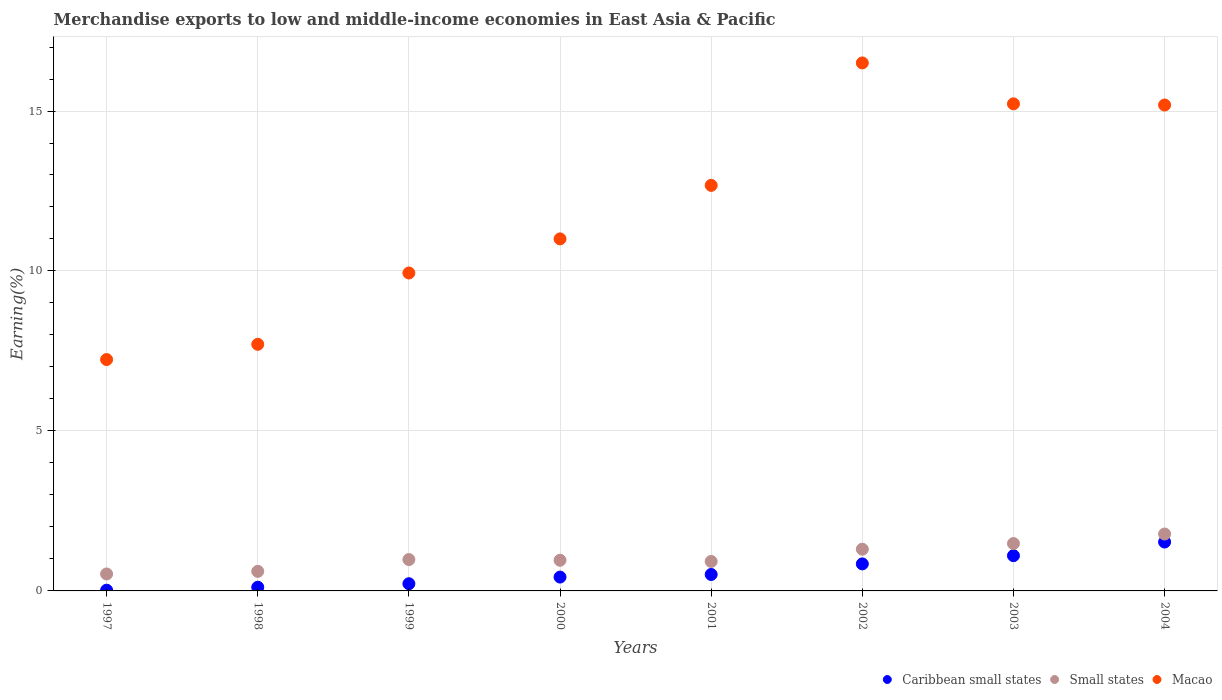How many different coloured dotlines are there?
Your response must be concise. 3. What is the percentage of amount earned from merchandise exports in Small states in 1997?
Your answer should be very brief. 0.53. Across all years, what is the maximum percentage of amount earned from merchandise exports in Macao?
Keep it short and to the point. 16.5. Across all years, what is the minimum percentage of amount earned from merchandise exports in Caribbean small states?
Your answer should be compact. 0.02. In which year was the percentage of amount earned from merchandise exports in Small states maximum?
Provide a succinct answer. 2004. In which year was the percentage of amount earned from merchandise exports in Caribbean small states minimum?
Offer a terse response. 1997. What is the total percentage of amount earned from merchandise exports in Macao in the graph?
Ensure brevity in your answer.  95.47. What is the difference between the percentage of amount earned from merchandise exports in Macao in 1997 and that in 2003?
Offer a very short reply. -7.99. What is the difference between the percentage of amount earned from merchandise exports in Small states in 2004 and the percentage of amount earned from merchandise exports in Caribbean small states in 2000?
Keep it short and to the point. 1.35. What is the average percentage of amount earned from merchandise exports in Caribbean small states per year?
Your answer should be compact. 0.6. In the year 1998, what is the difference between the percentage of amount earned from merchandise exports in Macao and percentage of amount earned from merchandise exports in Small states?
Give a very brief answer. 7.1. In how many years, is the percentage of amount earned from merchandise exports in Macao greater than 3 %?
Your answer should be very brief. 8. What is the ratio of the percentage of amount earned from merchandise exports in Small states in 1999 to that in 2000?
Offer a terse response. 1.02. What is the difference between the highest and the second highest percentage of amount earned from merchandise exports in Small states?
Your answer should be compact. 0.3. What is the difference between the highest and the lowest percentage of amount earned from merchandise exports in Macao?
Your response must be concise. 9.27. In how many years, is the percentage of amount earned from merchandise exports in Macao greater than the average percentage of amount earned from merchandise exports in Macao taken over all years?
Your answer should be very brief. 4. Is the sum of the percentage of amount earned from merchandise exports in Small states in 1998 and 2003 greater than the maximum percentage of amount earned from merchandise exports in Caribbean small states across all years?
Offer a terse response. Yes. Is it the case that in every year, the sum of the percentage of amount earned from merchandise exports in Macao and percentage of amount earned from merchandise exports in Caribbean small states  is greater than the percentage of amount earned from merchandise exports in Small states?
Your response must be concise. Yes. Does the percentage of amount earned from merchandise exports in Small states monotonically increase over the years?
Ensure brevity in your answer.  No. Is the percentage of amount earned from merchandise exports in Macao strictly less than the percentage of amount earned from merchandise exports in Caribbean small states over the years?
Your answer should be very brief. No. Are the values on the major ticks of Y-axis written in scientific E-notation?
Your answer should be very brief. No. Does the graph contain any zero values?
Provide a succinct answer. No. Where does the legend appear in the graph?
Ensure brevity in your answer.  Bottom right. How many legend labels are there?
Your answer should be very brief. 3. What is the title of the graph?
Provide a succinct answer. Merchandise exports to low and middle-income economies in East Asia & Pacific. What is the label or title of the Y-axis?
Make the answer very short. Earning(%). What is the Earning(%) of Caribbean small states in 1997?
Provide a short and direct response. 0.02. What is the Earning(%) of Small states in 1997?
Offer a terse response. 0.53. What is the Earning(%) in Macao in 1997?
Your answer should be very brief. 7.23. What is the Earning(%) of Caribbean small states in 1998?
Your answer should be compact. 0.12. What is the Earning(%) of Small states in 1998?
Your answer should be very brief. 0.61. What is the Earning(%) of Macao in 1998?
Offer a very short reply. 7.71. What is the Earning(%) in Caribbean small states in 1999?
Your answer should be compact. 0.22. What is the Earning(%) in Small states in 1999?
Give a very brief answer. 0.98. What is the Earning(%) in Macao in 1999?
Ensure brevity in your answer.  9.94. What is the Earning(%) of Caribbean small states in 2000?
Your answer should be very brief. 0.43. What is the Earning(%) in Small states in 2000?
Provide a succinct answer. 0.96. What is the Earning(%) of Macao in 2000?
Your response must be concise. 11. What is the Earning(%) of Caribbean small states in 2001?
Provide a succinct answer. 0.51. What is the Earning(%) of Small states in 2001?
Your answer should be very brief. 0.92. What is the Earning(%) in Macao in 2001?
Provide a succinct answer. 12.68. What is the Earning(%) in Caribbean small states in 2002?
Your response must be concise. 0.84. What is the Earning(%) in Small states in 2002?
Offer a terse response. 1.3. What is the Earning(%) of Macao in 2002?
Provide a succinct answer. 16.5. What is the Earning(%) in Caribbean small states in 2003?
Provide a short and direct response. 1.1. What is the Earning(%) in Small states in 2003?
Offer a very short reply. 1.48. What is the Earning(%) in Macao in 2003?
Your answer should be compact. 15.22. What is the Earning(%) in Caribbean small states in 2004?
Provide a short and direct response. 1.53. What is the Earning(%) of Small states in 2004?
Your answer should be very brief. 1.78. What is the Earning(%) in Macao in 2004?
Keep it short and to the point. 15.19. Across all years, what is the maximum Earning(%) in Caribbean small states?
Your response must be concise. 1.53. Across all years, what is the maximum Earning(%) in Small states?
Offer a terse response. 1.78. Across all years, what is the maximum Earning(%) of Macao?
Your answer should be compact. 16.5. Across all years, what is the minimum Earning(%) of Caribbean small states?
Your response must be concise. 0.02. Across all years, what is the minimum Earning(%) of Small states?
Your answer should be very brief. 0.53. Across all years, what is the minimum Earning(%) in Macao?
Make the answer very short. 7.23. What is the total Earning(%) in Caribbean small states in the graph?
Give a very brief answer. 4.79. What is the total Earning(%) of Small states in the graph?
Ensure brevity in your answer.  8.56. What is the total Earning(%) in Macao in the graph?
Offer a terse response. 95.47. What is the difference between the Earning(%) in Caribbean small states in 1997 and that in 1998?
Provide a short and direct response. -0.09. What is the difference between the Earning(%) of Small states in 1997 and that in 1998?
Offer a terse response. -0.08. What is the difference between the Earning(%) of Macao in 1997 and that in 1998?
Provide a short and direct response. -0.48. What is the difference between the Earning(%) in Caribbean small states in 1997 and that in 1999?
Provide a short and direct response. -0.2. What is the difference between the Earning(%) in Small states in 1997 and that in 1999?
Keep it short and to the point. -0.45. What is the difference between the Earning(%) of Macao in 1997 and that in 1999?
Provide a short and direct response. -2.71. What is the difference between the Earning(%) of Caribbean small states in 1997 and that in 2000?
Provide a short and direct response. -0.41. What is the difference between the Earning(%) of Small states in 1997 and that in 2000?
Make the answer very short. -0.43. What is the difference between the Earning(%) of Macao in 1997 and that in 2000?
Ensure brevity in your answer.  -3.77. What is the difference between the Earning(%) of Caribbean small states in 1997 and that in 2001?
Ensure brevity in your answer.  -0.49. What is the difference between the Earning(%) in Small states in 1997 and that in 2001?
Offer a terse response. -0.39. What is the difference between the Earning(%) of Macao in 1997 and that in 2001?
Give a very brief answer. -5.44. What is the difference between the Earning(%) of Caribbean small states in 1997 and that in 2002?
Your answer should be compact. -0.82. What is the difference between the Earning(%) in Small states in 1997 and that in 2002?
Make the answer very short. -0.77. What is the difference between the Earning(%) in Macao in 1997 and that in 2002?
Provide a short and direct response. -9.27. What is the difference between the Earning(%) in Caribbean small states in 1997 and that in 2003?
Your answer should be compact. -1.08. What is the difference between the Earning(%) in Small states in 1997 and that in 2003?
Ensure brevity in your answer.  -0.95. What is the difference between the Earning(%) in Macao in 1997 and that in 2003?
Your response must be concise. -7.99. What is the difference between the Earning(%) of Caribbean small states in 1997 and that in 2004?
Ensure brevity in your answer.  -1.5. What is the difference between the Earning(%) of Small states in 1997 and that in 2004?
Make the answer very short. -1.25. What is the difference between the Earning(%) in Macao in 1997 and that in 2004?
Provide a short and direct response. -7.96. What is the difference between the Earning(%) of Caribbean small states in 1998 and that in 1999?
Make the answer very short. -0.11. What is the difference between the Earning(%) in Small states in 1998 and that in 1999?
Offer a terse response. -0.37. What is the difference between the Earning(%) in Macao in 1998 and that in 1999?
Provide a succinct answer. -2.23. What is the difference between the Earning(%) of Caribbean small states in 1998 and that in 2000?
Offer a very short reply. -0.32. What is the difference between the Earning(%) in Small states in 1998 and that in 2000?
Provide a short and direct response. -0.35. What is the difference between the Earning(%) in Macao in 1998 and that in 2000?
Provide a succinct answer. -3.3. What is the difference between the Earning(%) of Caribbean small states in 1998 and that in 2001?
Your response must be concise. -0.4. What is the difference between the Earning(%) of Small states in 1998 and that in 2001?
Give a very brief answer. -0.31. What is the difference between the Earning(%) in Macao in 1998 and that in 2001?
Offer a terse response. -4.97. What is the difference between the Earning(%) in Caribbean small states in 1998 and that in 2002?
Provide a short and direct response. -0.73. What is the difference between the Earning(%) in Small states in 1998 and that in 2002?
Your answer should be compact. -0.69. What is the difference between the Earning(%) of Macao in 1998 and that in 2002?
Provide a short and direct response. -8.79. What is the difference between the Earning(%) of Caribbean small states in 1998 and that in 2003?
Your answer should be compact. -0.99. What is the difference between the Earning(%) of Small states in 1998 and that in 2003?
Make the answer very short. -0.87. What is the difference between the Earning(%) of Macao in 1998 and that in 2003?
Make the answer very short. -7.52. What is the difference between the Earning(%) of Caribbean small states in 1998 and that in 2004?
Provide a short and direct response. -1.41. What is the difference between the Earning(%) of Small states in 1998 and that in 2004?
Make the answer very short. -1.17. What is the difference between the Earning(%) in Macao in 1998 and that in 2004?
Offer a very short reply. -7.48. What is the difference between the Earning(%) in Caribbean small states in 1999 and that in 2000?
Your response must be concise. -0.21. What is the difference between the Earning(%) in Small states in 1999 and that in 2000?
Give a very brief answer. 0.02. What is the difference between the Earning(%) of Macao in 1999 and that in 2000?
Ensure brevity in your answer.  -1.07. What is the difference between the Earning(%) in Caribbean small states in 1999 and that in 2001?
Make the answer very short. -0.29. What is the difference between the Earning(%) of Small states in 1999 and that in 2001?
Keep it short and to the point. 0.06. What is the difference between the Earning(%) in Macao in 1999 and that in 2001?
Keep it short and to the point. -2.74. What is the difference between the Earning(%) of Caribbean small states in 1999 and that in 2002?
Provide a short and direct response. -0.62. What is the difference between the Earning(%) of Small states in 1999 and that in 2002?
Make the answer very short. -0.32. What is the difference between the Earning(%) of Macao in 1999 and that in 2002?
Provide a short and direct response. -6.57. What is the difference between the Earning(%) of Caribbean small states in 1999 and that in 2003?
Make the answer very short. -0.88. What is the difference between the Earning(%) in Small states in 1999 and that in 2003?
Your answer should be very brief. -0.5. What is the difference between the Earning(%) in Macao in 1999 and that in 2003?
Offer a very short reply. -5.29. What is the difference between the Earning(%) of Caribbean small states in 1999 and that in 2004?
Give a very brief answer. -1.3. What is the difference between the Earning(%) of Small states in 1999 and that in 2004?
Offer a very short reply. -0.8. What is the difference between the Earning(%) in Macao in 1999 and that in 2004?
Offer a terse response. -5.25. What is the difference between the Earning(%) in Caribbean small states in 2000 and that in 2001?
Give a very brief answer. -0.08. What is the difference between the Earning(%) of Small states in 2000 and that in 2001?
Provide a succinct answer. 0.04. What is the difference between the Earning(%) of Macao in 2000 and that in 2001?
Give a very brief answer. -1.67. What is the difference between the Earning(%) in Caribbean small states in 2000 and that in 2002?
Your response must be concise. -0.41. What is the difference between the Earning(%) of Small states in 2000 and that in 2002?
Offer a terse response. -0.35. What is the difference between the Earning(%) of Macao in 2000 and that in 2002?
Your response must be concise. -5.5. What is the difference between the Earning(%) of Caribbean small states in 2000 and that in 2003?
Your answer should be compact. -0.67. What is the difference between the Earning(%) in Small states in 2000 and that in 2003?
Offer a very short reply. -0.52. What is the difference between the Earning(%) in Macao in 2000 and that in 2003?
Keep it short and to the point. -4.22. What is the difference between the Earning(%) in Caribbean small states in 2000 and that in 2004?
Your response must be concise. -1.1. What is the difference between the Earning(%) in Small states in 2000 and that in 2004?
Provide a succinct answer. -0.82. What is the difference between the Earning(%) of Macao in 2000 and that in 2004?
Provide a succinct answer. -4.18. What is the difference between the Earning(%) in Caribbean small states in 2001 and that in 2002?
Keep it short and to the point. -0.33. What is the difference between the Earning(%) of Small states in 2001 and that in 2002?
Provide a short and direct response. -0.38. What is the difference between the Earning(%) in Macao in 2001 and that in 2002?
Your answer should be compact. -3.83. What is the difference between the Earning(%) of Caribbean small states in 2001 and that in 2003?
Offer a very short reply. -0.59. What is the difference between the Earning(%) in Small states in 2001 and that in 2003?
Your answer should be compact. -0.56. What is the difference between the Earning(%) in Macao in 2001 and that in 2003?
Make the answer very short. -2.55. What is the difference between the Earning(%) in Caribbean small states in 2001 and that in 2004?
Keep it short and to the point. -1.01. What is the difference between the Earning(%) in Small states in 2001 and that in 2004?
Your answer should be compact. -0.86. What is the difference between the Earning(%) of Macao in 2001 and that in 2004?
Provide a succinct answer. -2.51. What is the difference between the Earning(%) in Caribbean small states in 2002 and that in 2003?
Keep it short and to the point. -0.26. What is the difference between the Earning(%) of Small states in 2002 and that in 2003?
Your answer should be compact. -0.18. What is the difference between the Earning(%) of Macao in 2002 and that in 2003?
Keep it short and to the point. 1.28. What is the difference between the Earning(%) of Caribbean small states in 2002 and that in 2004?
Your response must be concise. -0.68. What is the difference between the Earning(%) of Small states in 2002 and that in 2004?
Provide a short and direct response. -0.47. What is the difference between the Earning(%) in Macao in 2002 and that in 2004?
Keep it short and to the point. 1.32. What is the difference between the Earning(%) of Caribbean small states in 2003 and that in 2004?
Your answer should be compact. -0.43. What is the difference between the Earning(%) of Small states in 2003 and that in 2004?
Keep it short and to the point. -0.3. What is the difference between the Earning(%) of Macao in 2003 and that in 2004?
Offer a terse response. 0.04. What is the difference between the Earning(%) of Caribbean small states in 1997 and the Earning(%) of Small states in 1998?
Keep it short and to the point. -0.59. What is the difference between the Earning(%) of Caribbean small states in 1997 and the Earning(%) of Macao in 1998?
Your answer should be compact. -7.68. What is the difference between the Earning(%) of Small states in 1997 and the Earning(%) of Macao in 1998?
Keep it short and to the point. -7.18. What is the difference between the Earning(%) in Caribbean small states in 1997 and the Earning(%) in Small states in 1999?
Make the answer very short. -0.96. What is the difference between the Earning(%) in Caribbean small states in 1997 and the Earning(%) in Macao in 1999?
Your answer should be very brief. -9.91. What is the difference between the Earning(%) of Small states in 1997 and the Earning(%) of Macao in 1999?
Give a very brief answer. -9.41. What is the difference between the Earning(%) of Caribbean small states in 1997 and the Earning(%) of Small states in 2000?
Your answer should be very brief. -0.94. What is the difference between the Earning(%) of Caribbean small states in 1997 and the Earning(%) of Macao in 2000?
Provide a short and direct response. -10.98. What is the difference between the Earning(%) of Small states in 1997 and the Earning(%) of Macao in 2000?
Make the answer very short. -10.47. What is the difference between the Earning(%) of Caribbean small states in 1997 and the Earning(%) of Small states in 2001?
Give a very brief answer. -0.9. What is the difference between the Earning(%) of Caribbean small states in 1997 and the Earning(%) of Macao in 2001?
Give a very brief answer. -12.65. What is the difference between the Earning(%) of Small states in 1997 and the Earning(%) of Macao in 2001?
Your response must be concise. -12.15. What is the difference between the Earning(%) of Caribbean small states in 1997 and the Earning(%) of Small states in 2002?
Offer a terse response. -1.28. What is the difference between the Earning(%) in Caribbean small states in 1997 and the Earning(%) in Macao in 2002?
Keep it short and to the point. -16.48. What is the difference between the Earning(%) in Small states in 1997 and the Earning(%) in Macao in 2002?
Offer a terse response. -15.97. What is the difference between the Earning(%) of Caribbean small states in 1997 and the Earning(%) of Small states in 2003?
Offer a terse response. -1.46. What is the difference between the Earning(%) of Caribbean small states in 1997 and the Earning(%) of Macao in 2003?
Your answer should be very brief. -15.2. What is the difference between the Earning(%) of Small states in 1997 and the Earning(%) of Macao in 2003?
Provide a short and direct response. -14.69. What is the difference between the Earning(%) of Caribbean small states in 1997 and the Earning(%) of Small states in 2004?
Offer a terse response. -1.75. What is the difference between the Earning(%) in Caribbean small states in 1997 and the Earning(%) in Macao in 2004?
Make the answer very short. -15.16. What is the difference between the Earning(%) in Small states in 1997 and the Earning(%) in Macao in 2004?
Your response must be concise. -14.66. What is the difference between the Earning(%) in Caribbean small states in 1998 and the Earning(%) in Small states in 1999?
Ensure brevity in your answer.  -0.86. What is the difference between the Earning(%) of Caribbean small states in 1998 and the Earning(%) of Macao in 1999?
Give a very brief answer. -9.82. What is the difference between the Earning(%) of Small states in 1998 and the Earning(%) of Macao in 1999?
Offer a terse response. -9.33. What is the difference between the Earning(%) in Caribbean small states in 1998 and the Earning(%) in Small states in 2000?
Offer a terse response. -0.84. What is the difference between the Earning(%) of Caribbean small states in 1998 and the Earning(%) of Macao in 2000?
Offer a terse response. -10.89. What is the difference between the Earning(%) in Small states in 1998 and the Earning(%) in Macao in 2000?
Keep it short and to the point. -10.39. What is the difference between the Earning(%) of Caribbean small states in 1998 and the Earning(%) of Small states in 2001?
Your answer should be compact. -0.81. What is the difference between the Earning(%) of Caribbean small states in 1998 and the Earning(%) of Macao in 2001?
Make the answer very short. -12.56. What is the difference between the Earning(%) in Small states in 1998 and the Earning(%) in Macao in 2001?
Make the answer very short. -12.06. What is the difference between the Earning(%) in Caribbean small states in 1998 and the Earning(%) in Small states in 2002?
Offer a terse response. -1.19. What is the difference between the Earning(%) of Caribbean small states in 1998 and the Earning(%) of Macao in 2002?
Your answer should be very brief. -16.39. What is the difference between the Earning(%) in Small states in 1998 and the Earning(%) in Macao in 2002?
Offer a terse response. -15.89. What is the difference between the Earning(%) of Caribbean small states in 1998 and the Earning(%) of Small states in 2003?
Offer a very short reply. -1.36. What is the difference between the Earning(%) of Caribbean small states in 1998 and the Earning(%) of Macao in 2003?
Your response must be concise. -15.11. What is the difference between the Earning(%) of Small states in 1998 and the Earning(%) of Macao in 2003?
Provide a succinct answer. -14.61. What is the difference between the Earning(%) in Caribbean small states in 1998 and the Earning(%) in Small states in 2004?
Ensure brevity in your answer.  -1.66. What is the difference between the Earning(%) of Caribbean small states in 1998 and the Earning(%) of Macao in 2004?
Ensure brevity in your answer.  -15.07. What is the difference between the Earning(%) in Small states in 1998 and the Earning(%) in Macao in 2004?
Provide a succinct answer. -14.58. What is the difference between the Earning(%) of Caribbean small states in 1999 and the Earning(%) of Small states in 2000?
Your answer should be very brief. -0.73. What is the difference between the Earning(%) in Caribbean small states in 1999 and the Earning(%) in Macao in 2000?
Give a very brief answer. -10.78. What is the difference between the Earning(%) in Small states in 1999 and the Earning(%) in Macao in 2000?
Keep it short and to the point. -10.02. What is the difference between the Earning(%) in Caribbean small states in 1999 and the Earning(%) in Small states in 2001?
Make the answer very short. -0.7. What is the difference between the Earning(%) of Caribbean small states in 1999 and the Earning(%) of Macao in 2001?
Keep it short and to the point. -12.45. What is the difference between the Earning(%) of Small states in 1999 and the Earning(%) of Macao in 2001?
Give a very brief answer. -11.7. What is the difference between the Earning(%) of Caribbean small states in 1999 and the Earning(%) of Small states in 2002?
Keep it short and to the point. -1.08. What is the difference between the Earning(%) in Caribbean small states in 1999 and the Earning(%) in Macao in 2002?
Ensure brevity in your answer.  -16.28. What is the difference between the Earning(%) in Small states in 1999 and the Earning(%) in Macao in 2002?
Make the answer very short. -15.52. What is the difference between the Earning(%) of Caribbean small states in 1999 and the Earning(%) of Small states in 2003?
Offer a terse response. -1.26. What is the difference between the Earning(%) in Caribbean small states in 1999 and the Earning(%) in Macao in 2003?
Give a very brief answer. -15. What is the difference between the Earning(%) of Small states in 1999 and the Earning(%) of Macao in 2003?
Offer a terse response. -14.24. What is the difference between the Earning(%) of Caribbean small states in 1999 and the Earning(%) of Small states in 2004?
Your response must be concise. -1.55. What is the difference between the Earning(%) of Caribbean small states in 1999 and the Earning(%) of Macao in 2004?
Offer a terse response. -14.96. What is the difference between the Earning(%) in Small states in 1999 and the Earning(%) in Macao in 2004?
Offer a terse response. -14.21. What is the difference between the Earning(%) in Caribbean small states in 2000 and the Earning(%) in Small states in 2001?
Give a very brief answer. -0.49. What is the difference between the Earning(%) in Caribbean small states in 2000 and the Earning(%) in Macao in 2001?
Your response must be concise. -12.24. What is the difference between the Earning(%) of Small states in 2000 and the Earning(%) of Macao in 2001?
Offer a terse response. -11.72. What is the difference between the Earning(%) in Caribbean small states in 2000 and the Earning(%) in Small states in 2002?
Provide a short and direct response. -0.87. What is the difference between the Earning(%) of Caribbean small states in 2000 and the Earning(%) of Macao in 2002?
Your answer should be compact. -16.07. What is the difference between the Earning(%) in Small states in 2000 and the Earning(%) in Macao in 2002?
Ensure brevity in your answer.  -15.54. What is the difference between the Earning(%) in Caribbean small states in 2000 and the Earning(%) in Small states in 2003?
Give a very brief answer. -1.05. What is the difference between the Earning(%) in Caribbean small states in 2000 and the Earning(%) in Macao in 2003?
Make the answer very short. -14.79. What is the difference between the Earning(%) in Small states in 2000 and the Earning(%) in Macao in 2003?
Offer a very short reply. -14.27. What is the difference between the Earning(%) of Caribbean small states in 2000 and the Earning(%) of Small states in 2004?
Your answer should be compact. -1.35. What is the difference between the Earning(%) of Caribbean small states in 2000 and the Earning(%) of Macao in 2004?
Provide a short and direct response. -14.75. What is the difference between the Earning(%) of Small states in 2000 and the Earning(%) of Macao in 2004?
Provide a succinct answer. -14.23. What is the difference between the Earning(%) of Caribbean small states in 2001 and the Earning(%) of Small states in 2002?
Ensure brevity in your answer.  -0.79. What is the difference between the Earning(%) in Caribbean small states in 2001 and the Earning(%) in Macao in 2002?
Your answer should be compact. -15.99. What is the difference between the Earning(%) in Small states in 2001 and the Earning(%) in Macao in 2002?
Ensure brevity in your answer.  -15.58. What is the difference between the Earning(%) of Caribbean small states in 2001 and the Earning(%) of Small states in 2003?
Provide a short and direct response. -0.97. What is the difference between the Earning(%) of Caribbean small states in 2001 and the Earning(%) of Macao in 2003?
Offer a terse response. -14.71. What is the difference between the Earning(%) in Small states in 2001 and the Earning(%) in Macao in 2003?
Your answer should be compact. -14.3. What is the difference between the Earning(%) in Caribbean small states in 2001 and the Earning(%) in Small states in 2004?
Provide a succinct answer. -1.26. What is the difference between the Earning(%) of Caribbean small states in 2001 and the Earning(%) of Macao in 2004?
Keep it short and to the point. -14.67. What is the difference between the Earning(%) in Small states in 2001 and the Earning(%) in Macao in 2004?
Keep it short and to the point. -14.27. What is the difference between the Earning(%) of Caribbean small states in 2002 and the Earning(%) of Small states in 2003?
Keep it short and to the point. -0.64. What is the difference between the Earning(%) of Caribbean small states in 2002 and the Earning(%) of Macao in 2003?
Make the answer very short. -14.38. What is the difference between the Earning(%) of Small states in 2002 and the Earning(%) of Macao in 2003?
Ensure brevity in your answer.  -13.92. What is the difference between the Earning(%) of Caribbean small states in 2002 and the Earning(%) of Small states in 2004?
Ensure brevity in your answer.  -0.93. What is the difference between the Earning(%) of Caribbean small states in 2002 and the Earning(%) of Macao in 2004?
Provide a short and direct response. -14.34. What is the difference between the Earning(%) in Small states in 2002 and the Earning(%) in Macao in 2004?
Make the answer very short. -13.88. What is the difference between the Earning(%) in Caribbean small states in 2003 and the Earning(%) in Small states in 2004?
Ensure brevity in your answer.  -0.68. What is the difference between the Earning(%) in Caribbean small states in 2003 and the Earning(%) in Macao in 2004?
Your answer should be compact. -14.09. What is the difference between the Earning(%) in Small states in 2003 and the Earning(%) in Macao in 2004?
Offer a very short reply. -13.71. What is the average Earning(%) of Caribbean small states per year?
Offer a terse response. 0.6. What is the average Earning(%) of Small states per year?
Provide a short and direct response. 1.07. What is the average Earning(%) in Macao per year?
Your response must be concise. 11.93. In the year 1997, what is the difference between the Earning(%) of Caribbean small states and Earning(%) of Small states?
Your answer should be very brief. -0.51. In the year 1997, what is the difference between the Earning(%) of Caribbean small states and Earning(%) of Macao?
Your answer should be compact. -7.21. In the year 1997, what is the difference between the Earning(%) in Small states and Earning(%) in Macao?
Your response must be concise. -6.7. In the year 1998, what is the difference between the Earning(%) in Caribbean small states and Earning(%) in Small states?
Ensure brevity in your answer.  -0.5. In the year 1998, what is the difference between the Earning(%) of Caribbean small states and Earning(%) of Macao?
Offer a very short reply. -7.59. In the year 1998, what is the difference between the Earning(%) of Small states and Earning(%) of Macao?
Offer a very short reply. -7.1. In the year 1999, what is the difference between the Earning(%) in Caribbean small states and Earning(%) in Small states?
Ensure brevity in your answer.  -0.76. In the year 1999, what is the difference between the Earning(%) of Caribbean small states and Earning(%) of Macao?
Ensure brevity in your answer.  -9.71. In the year 1999, what is the difference between the Earning(%) in Small states and Earning(%) in Macao?
Provide a short and direct response. -8.96. In the year 2000, what is the difference between the Earning(%) in Caribbean small states and Earning(%) in Small states?
Provide a short and direct response. -0.53. In the year 2000, what is the difference between the Earning(%) of Caribbean small states and Earning(%) of Macao?
Provide a succinct answer. -10.57. In the year 2000, what is the difference between the Earning(%) in Small states and Earning(%) in Macao?
Offer a very short reply. -10.04. In the year 2001, what is the difference between the Earning(%) of Caribbean small states and Earning(%) of Small states?
Offer a very short reply. -0.41. In the year 2001, what is the difference between the Earning(%) of Caribbean small states and Earning(%) of Macao?
Provide a succinct answer. -12.16. In the year 2001, what is the difference between the Earning(%) in Small states and Earning(%) in Macao?
Offer a very short reply. -11.75. In the year 2002, what is the difference between the Earning(%) of Caribbean small states and Earning(%) of Small states?
Make the answer very short. -0.46. In the year 2002, what is the difference between the Earning(%) in Caribbean small states and Earning(%) in Macao?
Offer a terse response. -15.66. In the year 2002, what is the difference between the Earning(%) in Small states and Earning(%) in Macao?
Provide a succinct answer. -15.2. In the year 2003, what is the difference between the Earning(%) in Caribbean small states and Earning(%) in Small states?
Offer a very short reply. -0.38. In the year 2003, what is the difference between the Earning(%) of Caribbean small states and Earning(%) of Macao?
Provide a short and direct response. -14.12. In the year 2003, what is the difference between the Earning(%) in Small states and Earning(%) in Macao?
Your answer should be very brief. -13.74. In the year 2004, what is the difference between the Earning(%) in Caribbean small states and Earning(%) in Small states?
Your response must be concise. -0.25. In the year 2004, what is the difference between the Earning(%) of Caribbean small states and Earning(%) of Macao?
Offer a very short reply. -13.66. In the year 2004, what is the difference between the Earning(%) of Small states and Earning(%) of Macao?
Make the answer very short. -13.41. What is the ratio of the Earning(%) in Caribbean small states in 1997 to that in 1998?
Provide a succinct answer. 0.2. What is the ratio of the Earning(%) of Small states in 1997 to that in 1998?
Offer a very short reply. 0.87. What is the ratio of the Earning(%) of Macao in 1997 to that in 1998?
Offer a terse response. 0.94. What is the ratio of the Earning(%) of Caribbean small states in 1997 to that in 1999?
Your answer should be compact. 0.1. What is the ratio of the Earning(%) of Small states in 1997 to that in 1999?
Your answer should be very brief. 0.54. What is the ratio of the Earning(%) of Macao in 1997 to that in 1999?
Offer a very short reply. 0.73. What is the ratio of the Earning(%) in Caribbean small states in 1997 to that in 2000?
Your answer should be very brief. 0.05. What is the ratio of the Earning(%) in Small states in 1997 to that in 2000?
Give a very brief answer. 0.55. What is the ratio of the Earning(%) in Macao in 1997 to that in 2000?
Give a very brief answer. 0.66. What is the ratio of the Earning(%) of Caribbean small states in 1997 to that in 2001?
Provide a short and direct response. 0.05. What is the ratio of the Earning(%) of Small states in 1997 to that in 2001?
Provide a short and direct response. 0.57. What is the ratio of the Earning(%) of Macao in 1997 to that in 2001?
Your answer should be compact. 0.57. What is the ratio of the Earning(%) in Caribbean small states in 1997 to that in 2002?
Provide a short and direct response. 0.03. What is the ratio of the Earning(%) of Small states in 1997 to that in 2002?
Your response must be concise. 0.41. What is the ratio of the Earning(%) in Macao in 1997 to that in 2002?
Provide a succinct answer. 0.44. What is the ratio of the Earning(%) of Caribbean small states in 1997 to that in 2003?
Your answer should be compact. 0.02. What is the ratio of the Earning(%) in Small states in 1997 to that in 2003?
Make the answer very short. 0.36. What is the ratio of the Earning(%) of Macao in 1997 to that in 2003?
Make the answer very short. 0.47. What is the ratio of the Earning(%) of Caribbean small states in 1997 to that in 2004?
Ensure brevity in your answer.  0.02. What is the ratio of the Earning(%) in Small states in 1997 to that in 2004?
Your response must be concise. 0.3. What is the ratio of the Earning(%) in Macao in 1997 to that in 2004?
Your response must be concise. 0.48. What is the ratio of the Earning(%) of Caribbean small states in 1998 to that in 1999?
Ensure brevity in your answer.  0.52. What is the ratio of the Earning(%) in Small states in 1998 to that in 1999?
Offer a very short reply. 0.62. What is the ratio of the Earning(%) in Macao in 1998 to that in 1999?
Make the answer very short. 0.78. What is the ratio of the Earning(%) of Caribbean small states in 1998 to that in 2000?
Provide a succinct answer. 0.27. What is the ratio of the Earning(%) of Small states in 1998 to that in 2000?
Your response must be concise. 0.64. What is the ratio of the Earning(%) of Macao in 1998 to that in 2000?
Provide a succinct answer. 0.7. What is the ratio of the Earning(%) of Caribbean small states in 1998 to that in 2001?
Provide a short and direct response. 0.23. What is the ratio of the Earning(%) of Small states in 1998 to that in 2001?
Keep it short and to the point. 0.66. What is the ratio of the Earning(%) of Macao in 1998 to that in 2001?
Your response must be concise. 0.61. What is the ratio of the Earning(%) of Caribbean small states in 1998 to that in 2002?
Offer a very short reply. 0.14. What is the ratio of the Earning(%) of Small states in 1998 to that in 2002?
Provide a succinct answer. 0.47. What is the ratio of the Earning(%) of Macao in 1998 to that in 2002?
Keep it short and to the point. 0.47. What is the ratio of the Earning(%) in Caribbean small states in 1998 to that in 2003?
Provide a short and direct response. 0.11. What is the ratio of the Earning(%) in Small states in 1998 to that in 2003?
Make the answer very short. 0.41. What is the ratio of the Earning(%) of Macao in 1998 to that in 2003?
Your answer should be compact. 0.51. What is the ratio of the Earning(%) of Caribbean small states in 1998 to that in 2004?
Ensure brevity in your answer.  0.08. What is the ratio of the Earning(%) of Small states in 1998 to that in 2004?
Your answer should be very brief. 0.34. What is the ratio of the Earning(%) of Macao in 1998 to that in 2004?
Your answer should be compact. 0.51. What is the ratio of the Earning(%) of Caribbean small states in 1999 to that in 2000?
Keep it short and to the point. 0.52. What is the ratio of the Earning(%) of Small states in 1999 to that in 2000?
Make the answer very short. 1.02. What is the ratio of the Earning(%) of Macao in 1999 to that in 2000?
Offer a very short reply. 0.9. What is the ratio of the Earning(%) in Caribbean small states in 1999 to that in 2001?
Provide a short and direct response. 0.44. What is the ratio of the Earning(%) of Small states in 1999 to that in 2001?
Your answer should be very brief. 1.06. What is the ratio of the Earning(%) in Macao in 1999 to that in 2001?
Your answer should be very brief. 0.78. What is the ratio of the Earning(%) in Caribbean small states in 1999 to that in 2002?
Provide a short and direct response. 0.27. What is the ratio of the Earning(%) in Small states in 1999 to that in 2002?
Give a very brief answer. 0.75. What is the ratio of the Earning(%) of Macao in 1999 to that in 2002?
Offer a very short reply. 0.6. What is the ratio of the Earning(%) in Caribbean small states in 1999 to that in 2003?
Keep it short and to the point. 0.2. What is the ratio of the Earning(%) of Small states in 1999 to that in 2003?
Your response must be concise. 0.66. What is the ratio of the Earning(%) of Macao in 1999 to that in 2003?
Keep it short and to the point. 0.65. What is the ratio of the Earning(%) in Caribbean small states in 1999 to that in 2004?
Offer a terse response. 0.15. What is the ratio of the Earning(%) of Small states in 1999 to that in 2004?
Provide a succinct answer. 0.55. What is the ratio of the Earning(%) in Macao in 1999 to that in 2004?
Make the answer very short. 0.65. What is the ratio of the Earning(%) in Caribbean small states in 2000 to that in 2001?
Ensure brevity in your answer.  0.84. What is the ratio of the Earning(%) in Small states in 2000 to that in 2001?
Offer a terse response. 1.04. What is the ratio of the Earning(%) in Macao in 2000 to that in 2001?
Make the answer very short. 0.87. What is the ratio of the Earning(%) of Caribbean small states in 2000 to that in 2002?
Your answer should be very brief. 0.51. What is the ratio of the Earning(%) of Small states in 2000 to that in 2002?
Make the answer very short. 0.73. What is the ratio of the Earning(%) in Macao in 2000 to that in 2002?
Ensure brevity in your answer.  0.67. What is the ratio of the Earning(%) of Caribbean small states in 2000 to that in 2003?
Provide a succinct answer. 0.39. What is the ratio of the Earning(%) of Small states in 2000 to that in 2003?
Your answer should be compact. 0.65. What is the ratio of the Earning(%) in Macao in 2000 to that in 2003?
Offer a terse response. 0.72. What is the ratio of the Earning(%) in Caribbean small states in 2000 to that in 2004?
Keep it short and to the point. 0.28. What is the ratio of the Earning(%) in Small states in 2000 to that in 2004?
Offer a very short reply. 0.54. What is the ratio of the Earning(%) in Macao in 2000 to that in 2004?
Give a very brief answer. 0.72. What is the ratio of the Earning(%) in Caribbean small states in 2001 to that in 2002?
Your answer should be very brief. 0.61. What is the ratio of the Earning(%) of Small states in 2001 to that in 2002?
Offer a very short reply. 0.71. What is the ratio of the Earning(%) in Macao in 2001 to that in 2002?
Give a very brief answer. 0.77. What is the ratio of the Earning(%) of Caribbean small states in 2001 to that in 2003?
Ensure brevity in your answer.  0.47. What is the ratio of the Earning(%) of Small states in 2001 to that in 2003?
Offer a terse response. 0.62. What is the ratio of the Earning(%) in Macao in 2001 to that in 2003?
Make the answer very short. 0.83. What is the ratio of the Earning(%) of Caribbean small states in 2001 to that in 2004?
Give a very brief answer. 0.34. What is the ratio of the Earning(%) in Small states in 2001 to that in 2004?
Your answer should be compact. 0.52. What is the ratio of the Earning(%) in Macao in 2001 to that in 2004?
Make the answer very short. 0.83. What is the ratio of the Earning(%) in Caribbean small states in 2002 to that in 2003?
Offer a very short reply. 0.77. What is the ratio of the Earning(%) in Small states in 2002 to that in 2003?
Your answer should be very brief. 0.88. What is the ratio of the Earning(%) in Macao in 2002 to that in 2003?
Give a very brief answer. 1.08. What is the ratio of the Earning(%) of Caribbean small states in 2002 to that in 2004?
Provide a short and direct response. 0.55. What is the ratio of the Earning(%) of Small states in 2002 to that in 2004?
Your response must be concise. 0.73. What is the ratio of the Earning(%) in Macao in 2002 to that in 2004?
Make the answer very short. 1.09. What is the ratio of the Earning(%) of Caribbean small states in 2003 to that in 2004?
Your answer should be compact. 0.72. What is the ratio of the Earning(%) of Small states in 2003 to that in 2004?
Provide a short and direct response. 0.83. What is the ratio of the Earning(%) of Macao in 2003 to that in 2004?
Your answer should be very brief. 1. What is the difference between the highest and the second highest Earning(%) in Caribbean small states?
Offer a terse response. 0.43. What is the difference between the highest and the second highest Earning(%) of Small states?
Offer a very short reply. 0.3. What is the difference between the highest and the second highest Earning(%) in Macao?
Provide a succinct answer. 1.28. What is the difference between the highest and the lowest Earning(%) in Caribbean small states?
Your answer should be very brief. 1.5. What is the difference between the highest and the lowest Earning(%) in Small states?
Keep it short and to the point. 1.25. What is the difference between the highest and the lowest Earning(%) in Macao?
Ensure brevity in your answer.  9.27. 